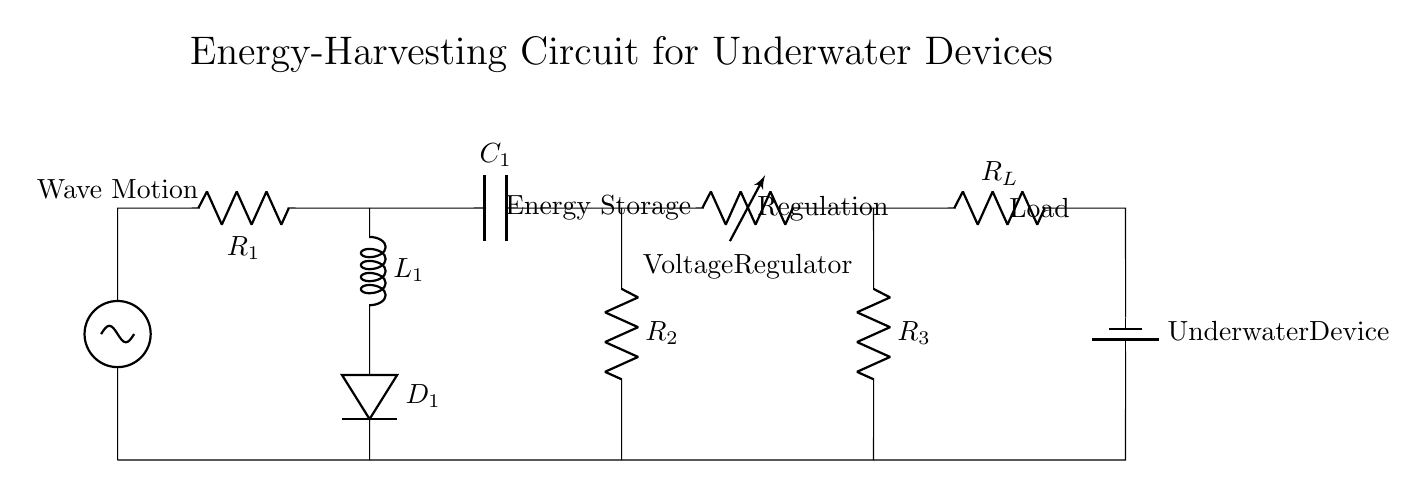What is the energy source in this circuit? The energy source is a wave motion generator, depicted by the sine wave symbol at the left side of the diagram.
Answer: wave motion generator What is the role of capacitor C1? C1 is an energy storage component, indicated in the circuit diagram that connects to the energy storage section. Its role is to store electrical energy generated from wave motion.
Answer: energy storage What type of load is represented in the circuit? The load represented is an underwater device, which is shown at the far right of the diagram connected to a resistor labeled R_L.
Answer: underwater device What component regulates the voltage before it reaches the load? The component that regulates the voltage is labeled as a voltage regulator in the diagram, located between the energy storage and load.
Answer: voltage regulator How many resistors are present in the circuit? There are three resistors present in the circuit, as indicated by the three R labels labeled R1, R2, and R3.
Answer: three What is the potential disadvantage of using wave motion for energy harvesting? A potential disadvantage is that the energy harvested depends on wave strength and consistency, impacting the reliability and efficiency of power generation underwater.
Answer: energy dependency Describe the connection between the inductor and the diode. The inductor, marked as L1, is connected in series with the diode D1. This means that the current must pass through the inductor first before reaching the diode, affecting the overall current flow.
Answer: series connection 